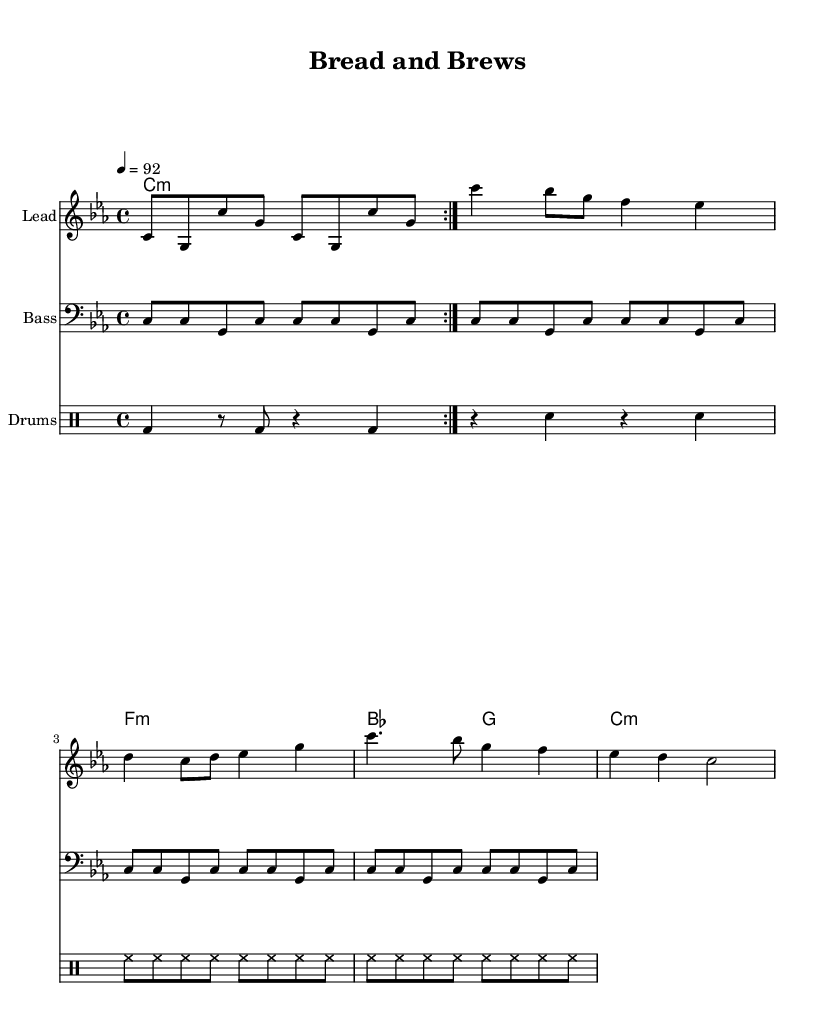what is the key signature of this music? The key signature is C minor, indicated by three flats in the context of the piece.
Answer: C minor what is the time signature of this music? The time signature is 4/4, which is noted at the beginning of the score indicating four beats per measure.
Answer: 4/4 what is the tempo of the piece? The tempo marking indicates a speed of 92 beats per minute, specified by the term '4 = 92.'
Answer: 92 how many measures are in the melody section? There are eight measures in the melody, as counted in the provided notes section.
Answer: 8 what type of instrument is indicated for the lead melody? The staff is labeled "Lead," indicating a single instrument is intended for the melody section.
Answer: Lead what is the main lyric or thematic element of this song as it relates to food? The title "Bread and Brews" signifies that the song features themes related to food and beverages, typical in hip hop.
Answer: Bread and Brews how do the drum patterns contribute to the overall feel of the hip hop genre? The drum patterns include bass drums and snare that create a strong backbeat and rhythmic foundation characteristic of hip hop music.
Answer: Strong backbeat 